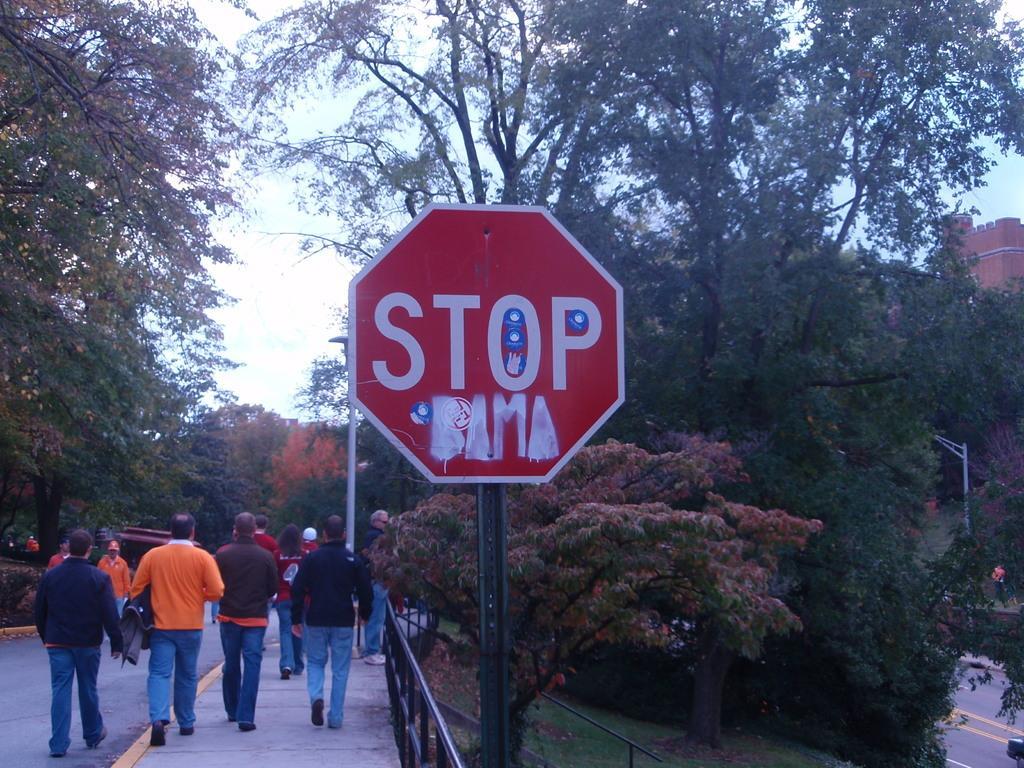In one or two sentences, can you explain what this image depicts? In the image there is a sign board in the middle with a road on the left side with few people walking on it and there are trees in the background all over the image. 